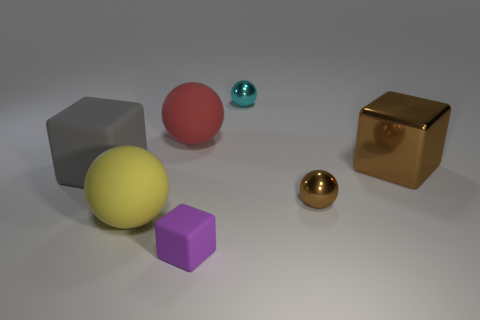Subtract all big yellow spheres. How many spheres are left? 3 Add 1 large red metal cylinders. How many objects exist? 8 Subtract all gray cubes. How many cubes are left? 2 Subtract all balls. How many objects are left? 3 Subtract all brown blocks. Subtract all gray matte objects. How many objects are left? 5 Add 3 large yellow spheres. How many large yellow spheres are left? 4 Add 2 large blue metallic cylinders. How many large blue metallic cylinders exist? 2 Subtract 0 purple cylinders. How many objects are left? 7 Subtract 3 cubes. How many cubes are left? 0 Subtract all red blocks. Subtract all purple spheres. How many blocks are left? 3 